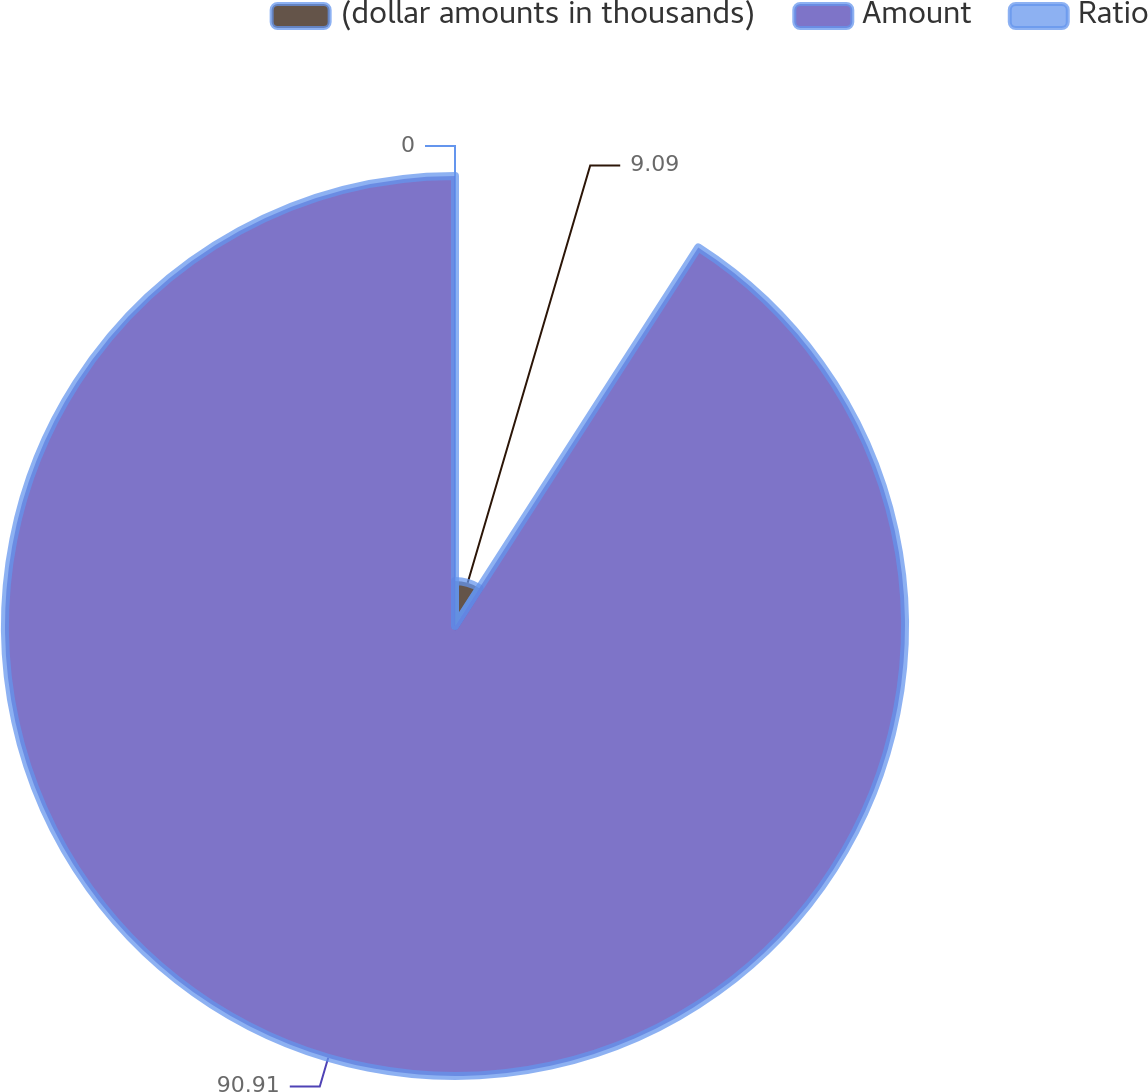Convert chart to OTSL. <chart><loc_0><loc_0><loc_500><loc_500><pie_chart><fcel>(dollar amounts in thousands)<fcel>Amount<fcel>Ratio<nl><fcel>9.09%<fcel>90.91%<fcel>0.0%<nl></chart> 